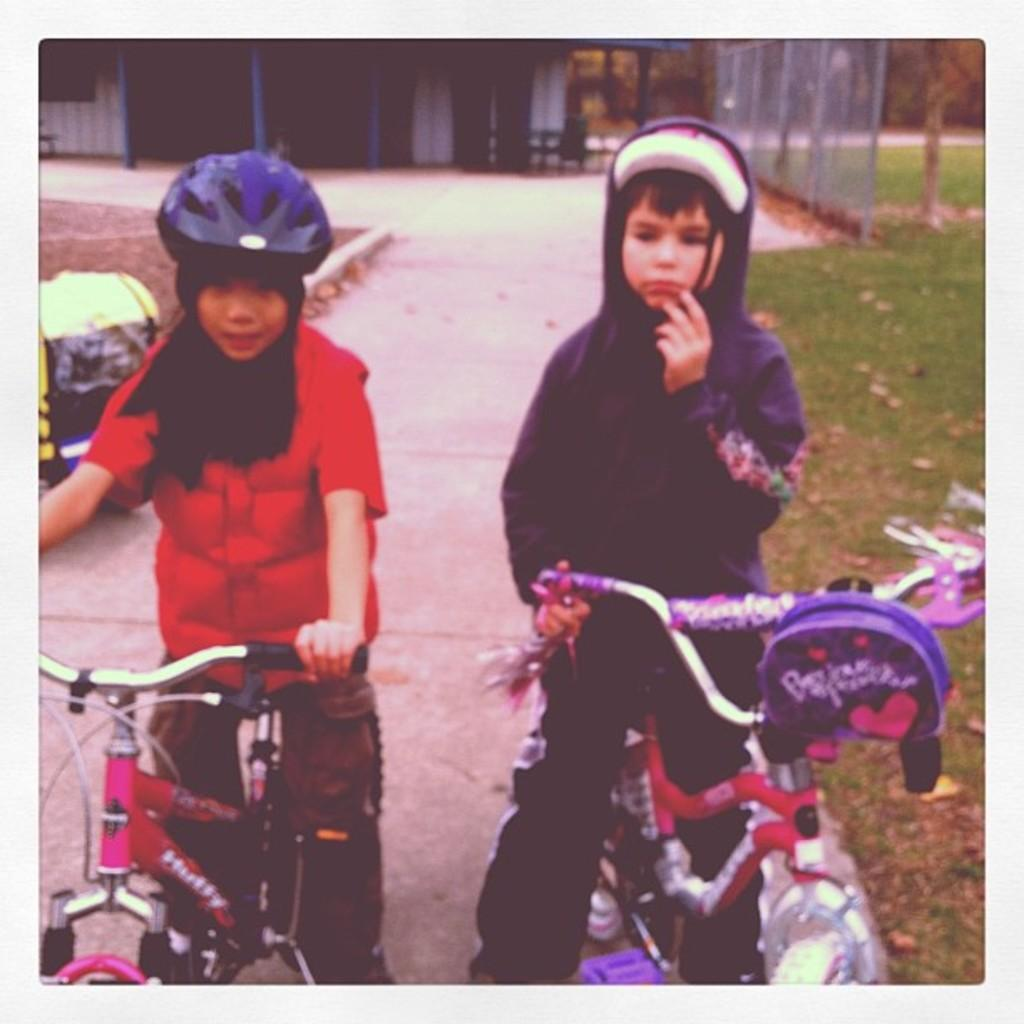How many children are in the image? There are two children in the image. What are the children doing in the image? The children are on their cycles. What can be seen in the background of the image? There is a path and a building in the background of the image. What type of locket is the grandmother wearing in the image? There is no grandmother or locket present in the image. How does the turkey interact with the children on their cycles in the image? There is no turkey present in the image; the children are riding their cycles without any interaction with a turkey. 